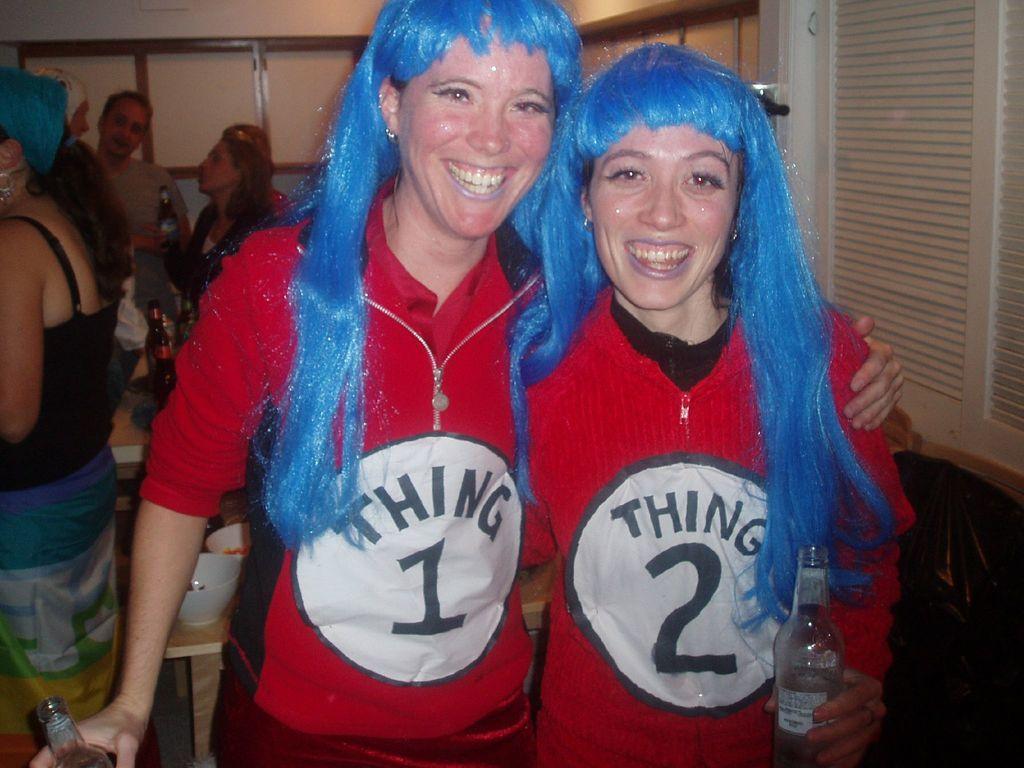Who is the taller woman dressed up as?
Make the answer very short. Thing 1. What is written on the shirt of the lady on the left?
Your answer should be very brief. Thing 1. 